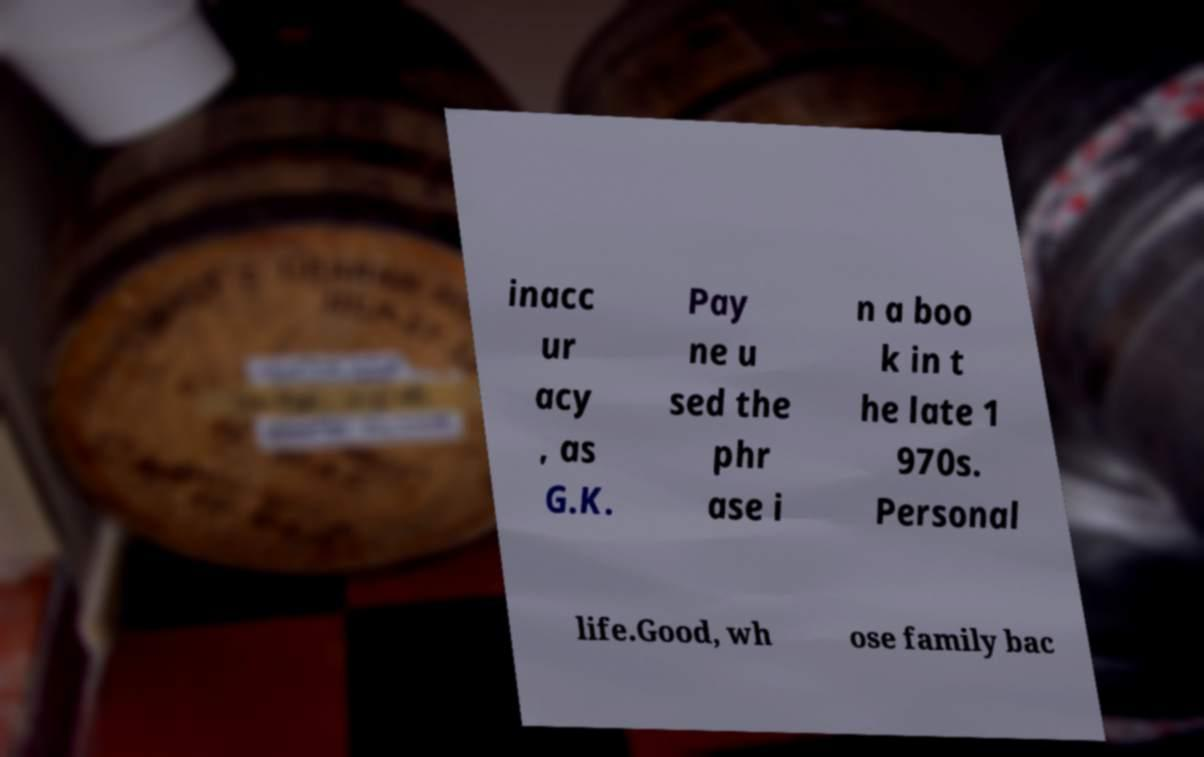There's text embedded in this image that I need extracted. Can you transcribe it verbatim? inacc ur acy , as G.K. Pay ne u sed the phr ase i n a boo k in t he late 1 970s. Personal life.Good, wh ose family bac 